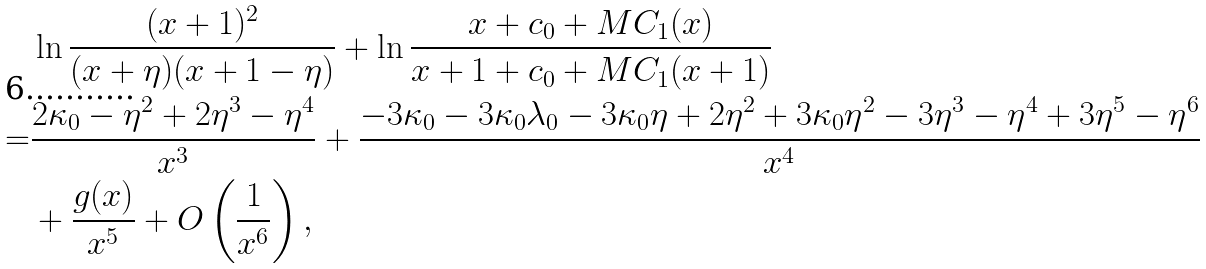Convert formula to latex. <formula><loc_0><loc_0><loc_500><loc_500>& \ln \frac { ( x + 1 ) ^ { 2 } } { ( x + \eta ) ( x + 1 - \eta ) } + \ln \frac { x + c _ { 0 } + M C _ { 1 } ( x ) } { x + 1 + c _ { 0 } + M C _ { 1 } ( x + 1 ) } \\ = & \frac { 2 \kappa _ { 0 } - \eta ^ { 2 } + 2 \eta ^ { 3 } - \eta ^ { 4 } } { x ^ { 3 } } + \frac { - 3 \kappa _ { 0 } - 3 \kappa _ { 0 } \lambda _ { 0 } - 3 \kappa _ { 0 } \eta + 2 \eta ^ { 2 } + 3 \kappa _ { 0 } \eta ^ { 2 } - 3 \eta ^ { 3 } - \eta ^ { 4 } + 3 \eta ^ { 5 } - \eta ^ { 6 } } { x ^ { 4 } } \\ & + \frac { g ( x ) } { x ^ { 5 } } + O \left ( \frac { 1 } { x ^ { 6 } } \right ) ,</formula> 